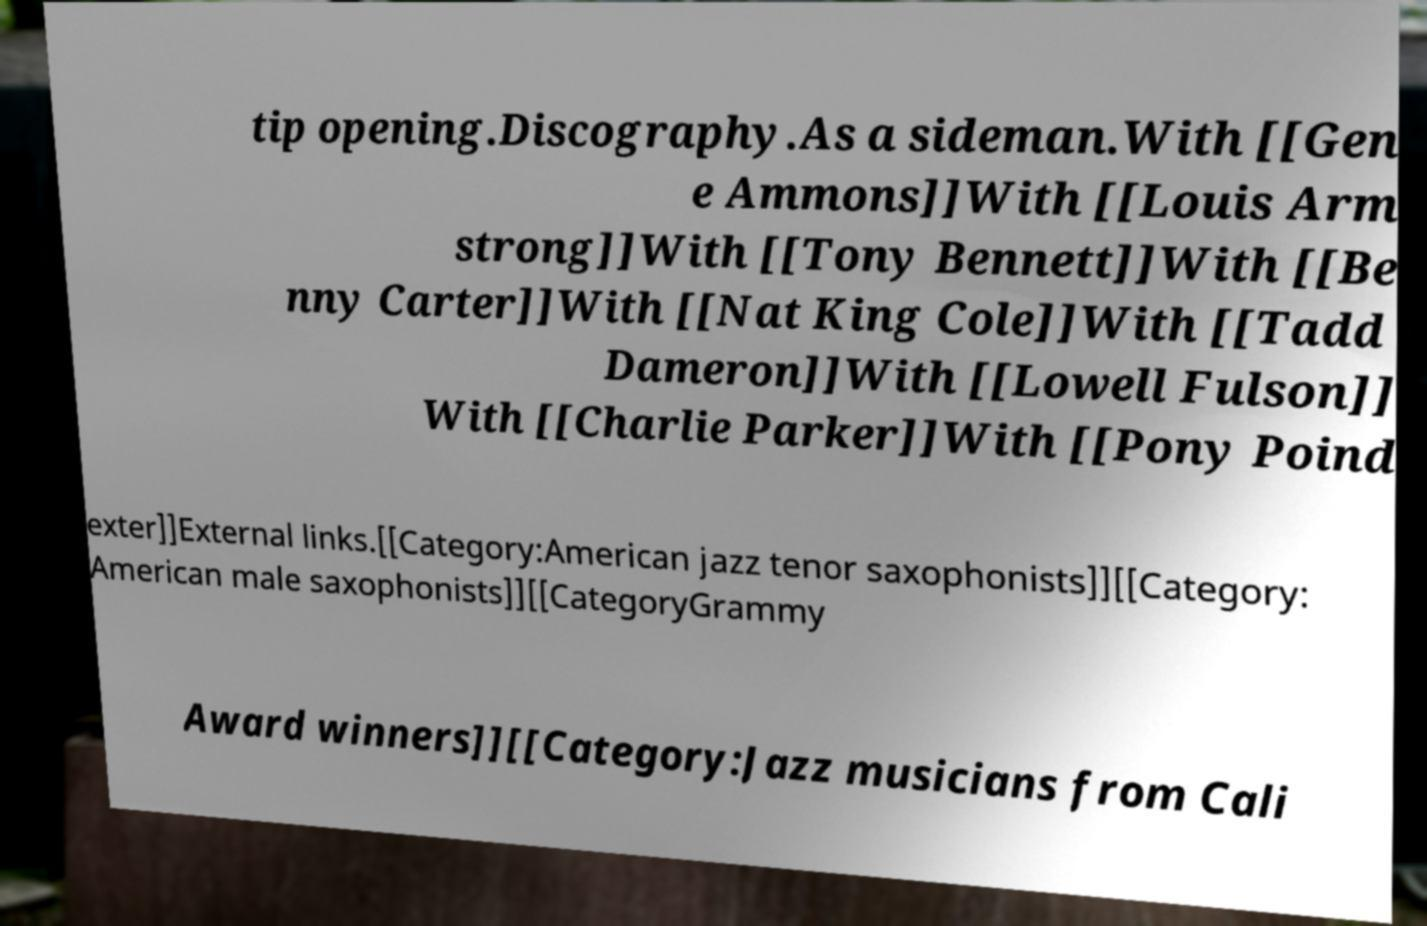Please identify and transcribe the text found in this image. tip opening.Discography.As a sideman.With [[Gen e Ammons]]With [[Louis Arm strong]]With [[Tony Bennett]]With [[Be nny Carter]]With [[Nat King Cole]]With [[Tadd Dameron]]With [[Lowell Fulson]] With [[Charlie Parker]]With [[Pony Poind exter]]External links.[[Category:American jazz tenor saxophonists]][[Category: American male saxophonists]][[CategoryGrammy Award winners]][[Category:Jazz musicians from Cali 